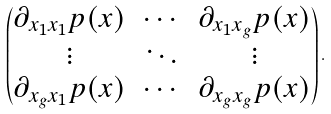Convert formula to latex. <formula><loc_0><loc_0><loc_500><loc_500>\begin{pmatrix} \partial _ { x _ { 1 } x _ { 1 } } p ( x ) & \cdots & \partial _ { x _ { 1 } x _ { g } } p ( x ) \\ \vdots & \ddots & \vdots \\ \partial _ { x _ { g } x _ { 1 } } p ( x ) & \cdots & \partial _ { x _ { g } x _ { g } } p ( x ) \end{pmatrix} .</formula> 